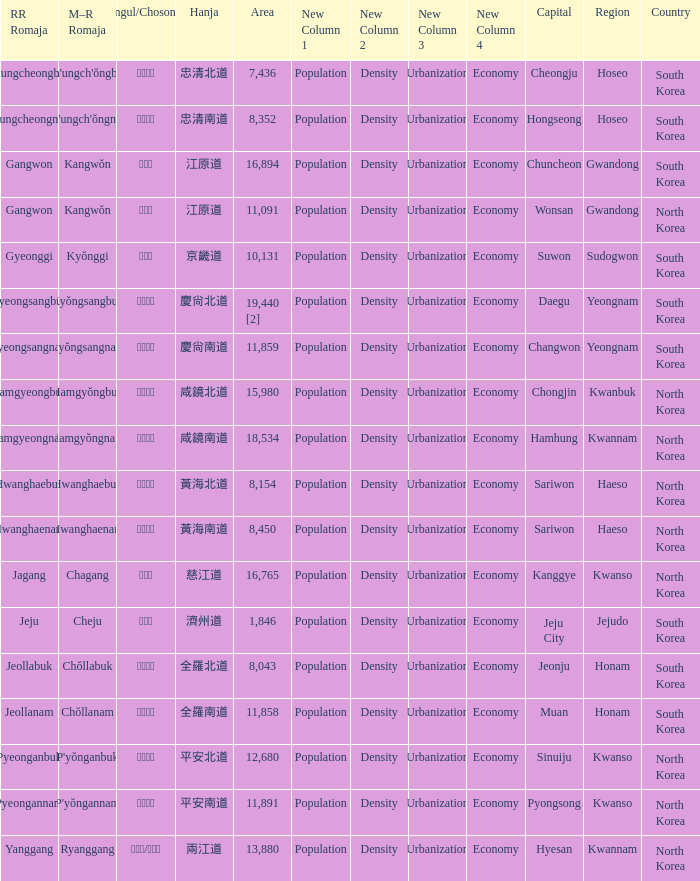Which capital has a Hangul of 경상남도? Changwon. 